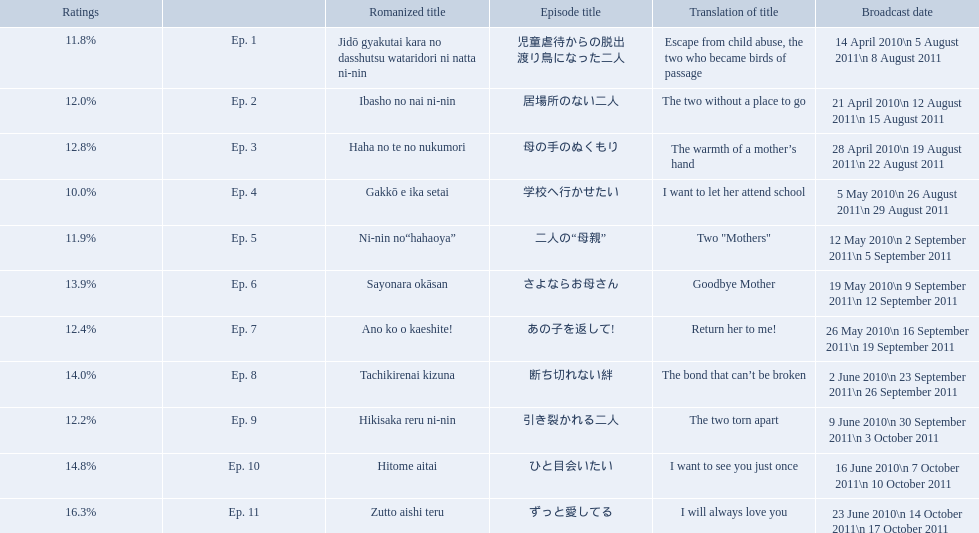What were the episode titles of mother? 児童虐待からの脱出 渡り鳥になった二人, 居場所のない二人, 母の手のぬくもり, 学校へ行かせたい, 二人の“母親”, さよならお母さん, あの子を返して!, 断ち切れない絆, 引き裂かれる二人, ひと目会いたい, ずっと愛してる. Which of these episodes had the highest ratings? ずっと愛してる. What are all the titles the episodes of the mother tv series? 児童虐待からの脱出 渡り鳥になった二人, 居場所のない二人, 母の手のぬくもり, 学校へ行かせたい, 二人の“母親”, さよならお母さん, あの子を返して!, 断ち切れない絆, 引き裂かれる二人, ひと目会いたい, ずっと愛してる. What are all of the ratings for each of the shows? 11.8%, 12.0%, 12.8%, 10.0%, 11.9%, 13.9%, 12.4%, 14.0%, 12.2%, 14.8%, 16.3%. What is the highest score for ratings? 16.3%. What episode corresponds to that rating? ずっと愛してる. What are all of the episode numbers? Ep. 1, Ep. 2, Ep. 3, Ep. 4, Ep. 5, Ep. 6, Ep. 7, Ep. 8, Ep. 9, Ep. 10, Ep. 11. And their titles? 児童虐待からの脱出 渡り鳥になった二人, 居場所のない二人, 母の手のぬくもり, 学校へ行かせたい, 二人の“母親”, さよならお母さん, あの子を返して!, 断ち切れない絆, 引き裂かれる二人, ひと目会いたい, ずっと愛してる. What about their translated names? Escape from child abuse, the two who became birds of passage, The two without a place to go, The warmth of a mother’s hand, I want to let her attend school, Two "Mothers", Goodbye Mother, Return her to me!, The bond that can’t be broken, The two torn apart, I want to see you just once, I will always love you. Which episode number's title translated to i want to let her attend school? Ep. 4. What are all the episodes? Ep. 1, Ep. 2, Ep. 3, Ep. 4, Ep. 5, Ep. 6, Ep. 7, Ep. 8, Ep. 9, Ep. 10, Ep. 11. Of these, which ones have a rating of 14%? Ep. 8, Ep. 10. Of these, which one is not ep. 10? Ep. 8. 